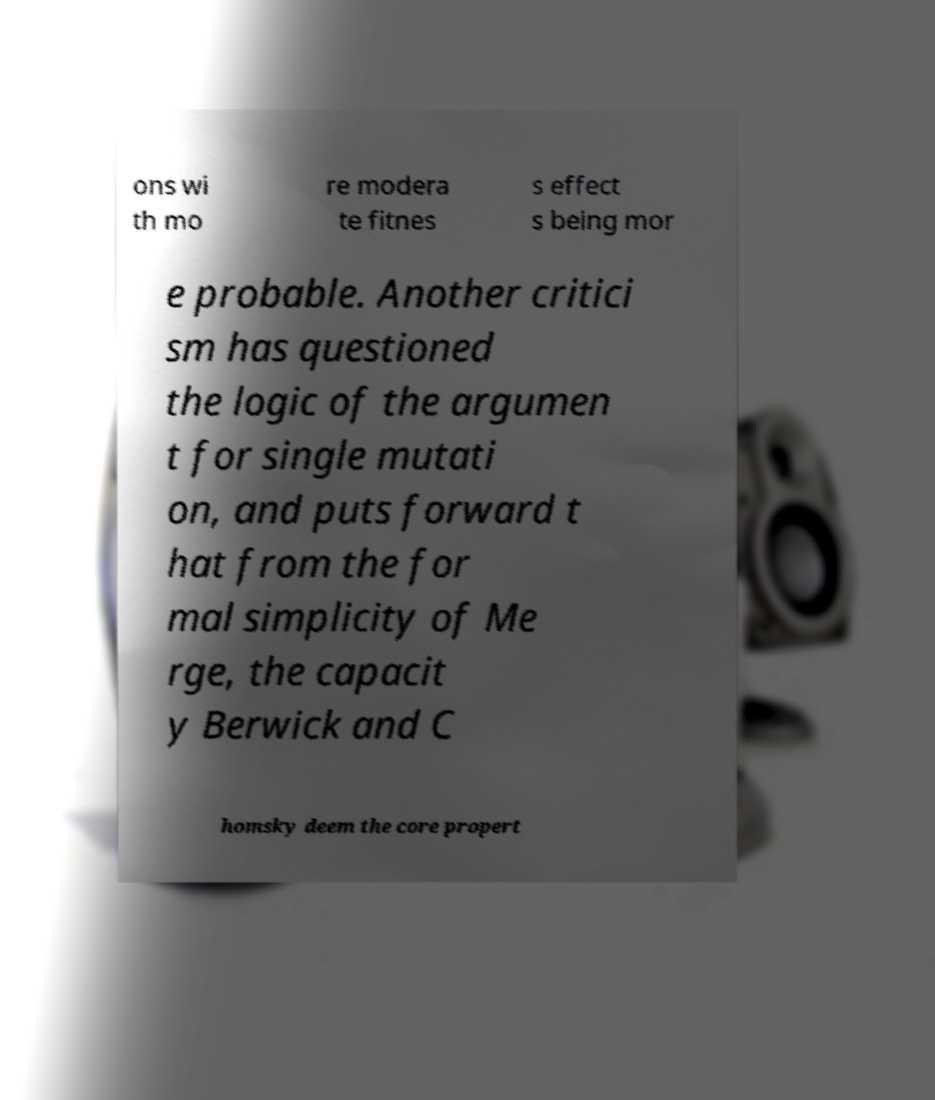Can you accurately transcribe the text from the provided image for me? ons wi th mo re modera te fitnes s effect s being mor e probable. Another critici sm has questioned the logic of the argumen t for single mutati on, and puts forward t hat from the for mal simplicity of Me rge, the capacit y Berwick and C homsky deem the core propert 